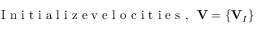<formula> <loc_0><loc_0><loc_500><loc_500>I n i t i a l i z e v e l o c i t i e s , { V } = \{ { V } _ { I } \}</formula> 